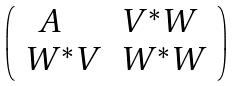<formula> <loc_0><loc_0><loc_500><loc_500>\left ( \begin{array} { l l } \ \ A & V ^ { * } W \\ W ^ { * } V & W ^ { * } W \end{array} \right )</formula> 